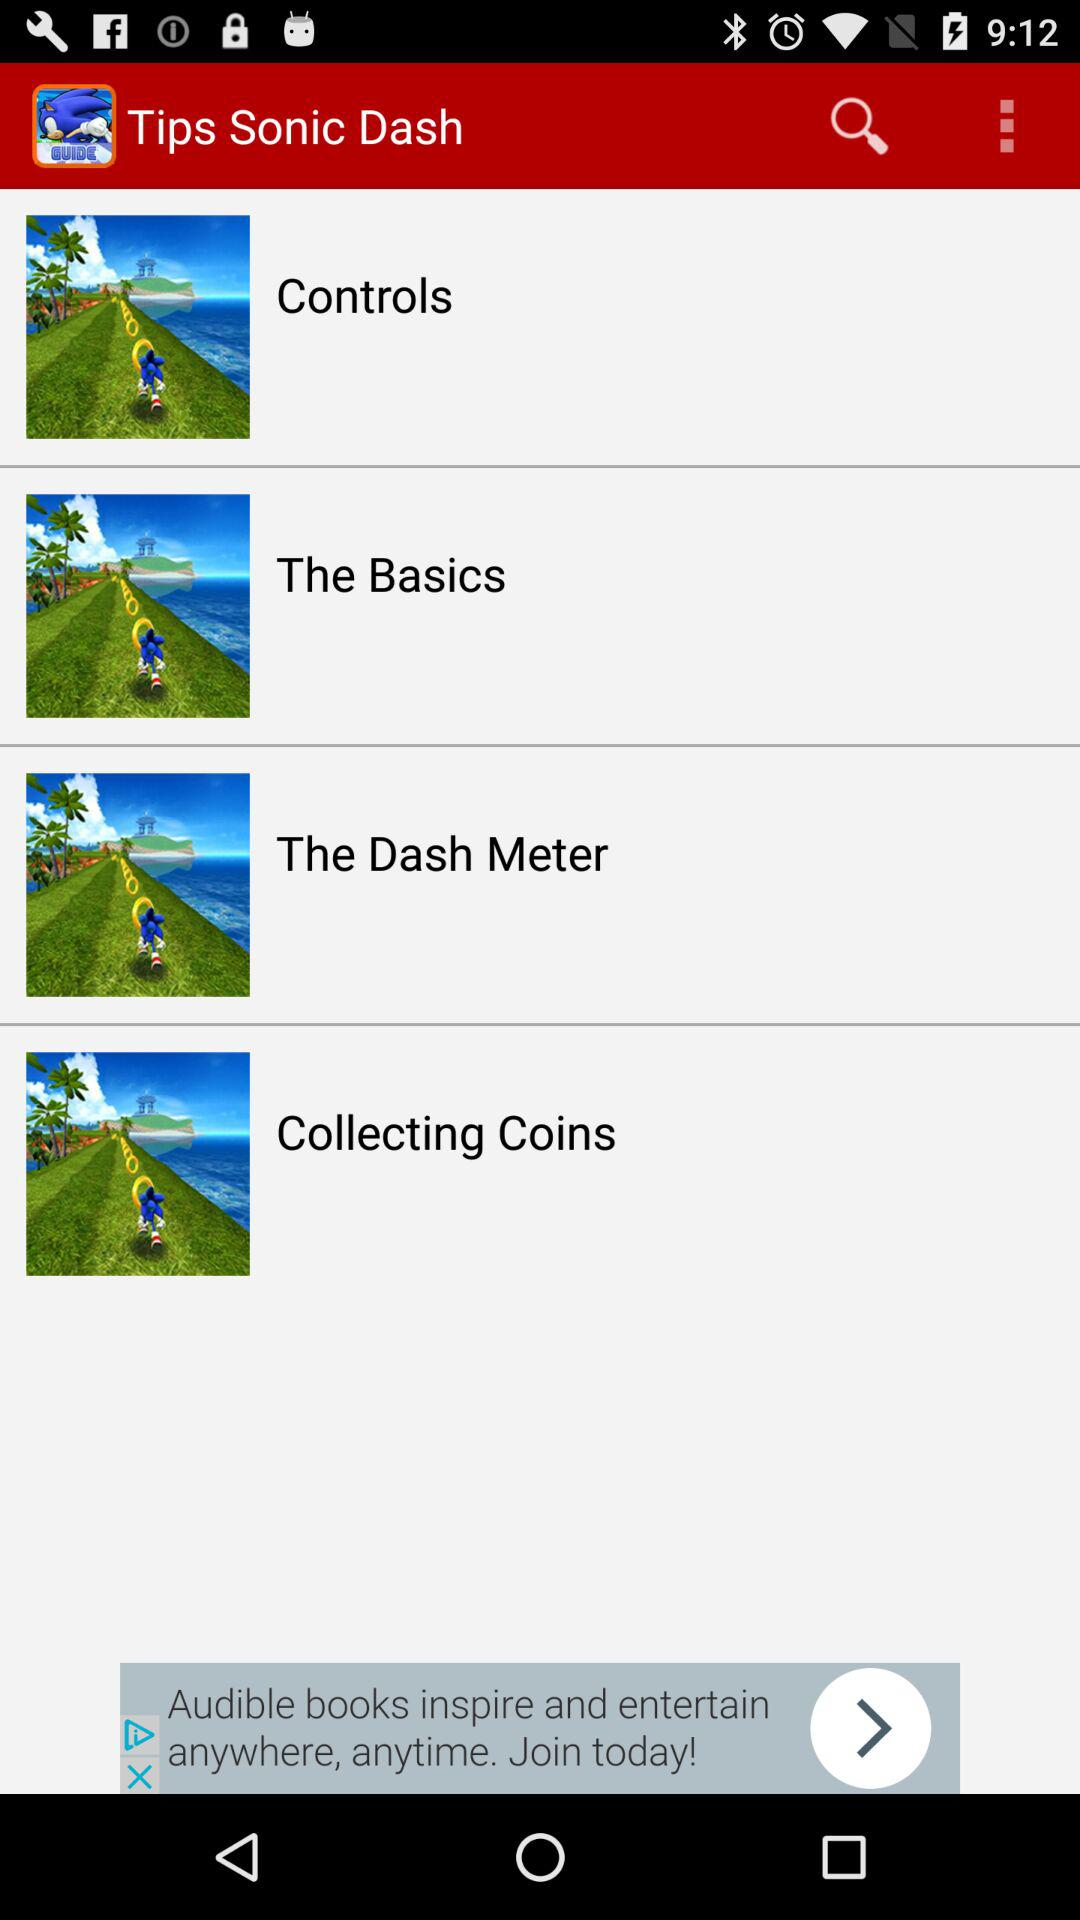What is the application name? The application name is "Tips Sonic Dash". 